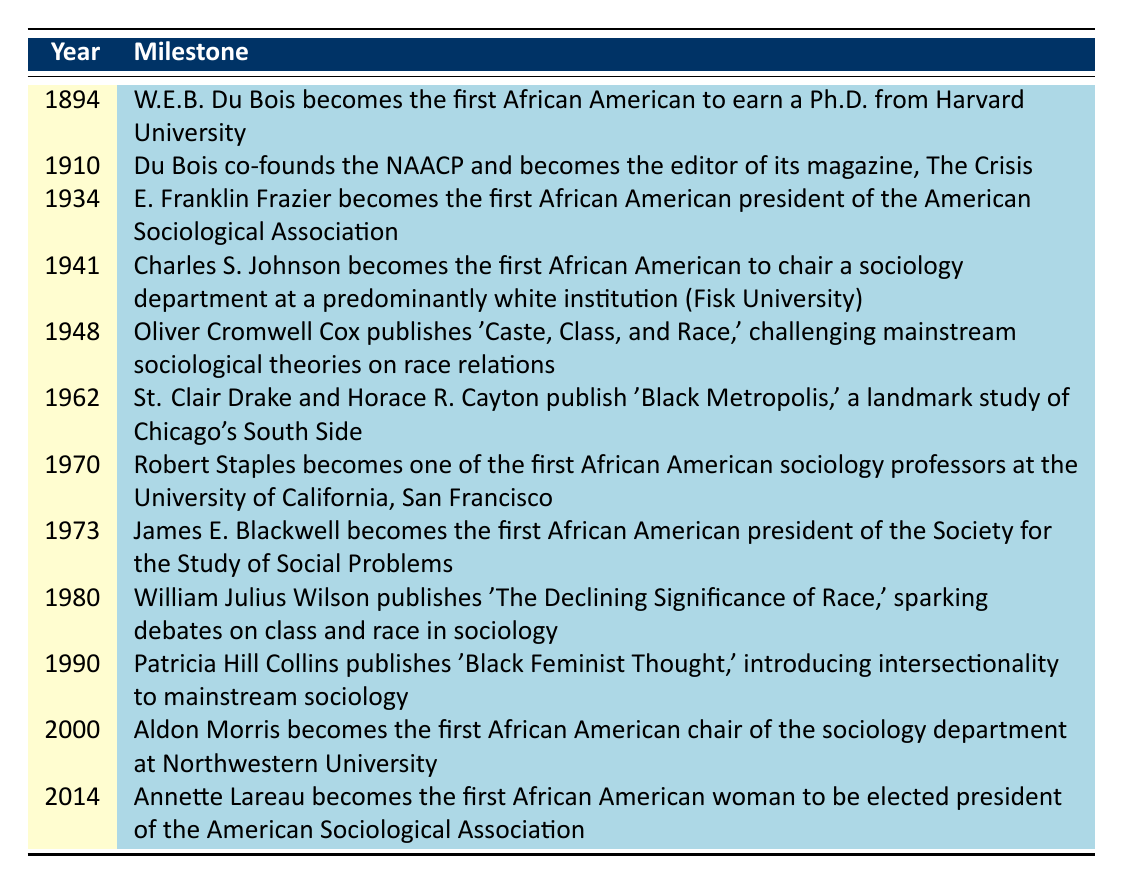What year did W.E.B. Du Bois earn his Ph.D. from Harvard? The table lists the event in the year 1894, stating that W.E.B. Du Bois becomes the first African American to earn a Ph.D. from Harvard University.
Answer: 1894 Which event marks the first African American presidency of the American Sociological Association? The table includes the event for the year 1934 where E. Franklin Frazier becomes the first African American president of the American Sociological Association.
Answer: E. Franklin Frazier becomes the first African American president in 1934 How many years separate Charles S. Johnson's chair position and William Julius Wilson's publication related to race? Charles S. Johnson becomes chair in 1941 and William Julius Wilson publishes his work in 1980. The difference is 1980 - 1941 = 39 years.
Answer: 39 years Did Patricia Hill Collins's publication contribute to introducing intersectionality to sociology? The table records that in 1990, Patricia Hill Collins publishes 'Black Feminist Thought,' which is explicitly stated as introducing intersectionality to mainstream sociology, confirming the statement is true.
Answer: Yes What trend can be observed regarding the years when significant milestones occurred in African American sociology from 1894 to 2014? If you analyze the table, you can see that there is a gradual increase in milestones over time, with notable contributions emerging in the 1960s and onward, indicating growing integration into mainstream academic institutions.
Answer: Increasing milestones over time 